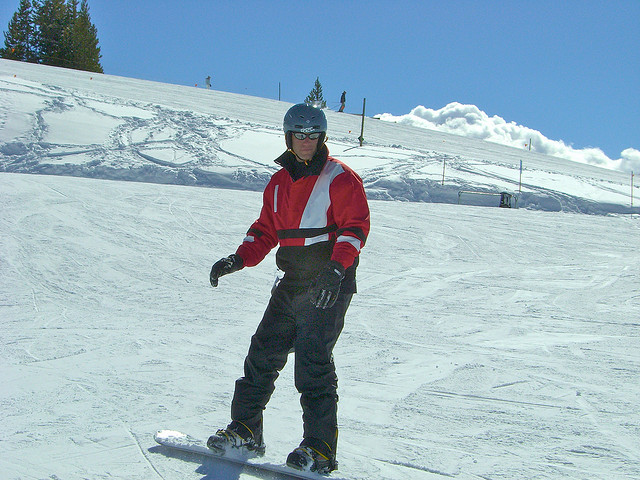<image>How much snow is on the floor? I don't know how much snow is on the floor. It could be a lot or just a light amount. How much snow is on the floor? It is ambiguous how much snow is on the floor. It can be seen a lot. 